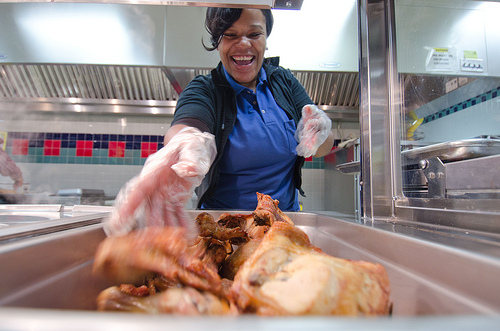<image>
Is there a plastic bag in the woman? No. The plastic bag is not contained within the woman. These objects have a different spatial relationship. Is there a chicken in front of the person? Yes. The chicken is positioned in front of the person, appearing closer to the camera viewpoint. 